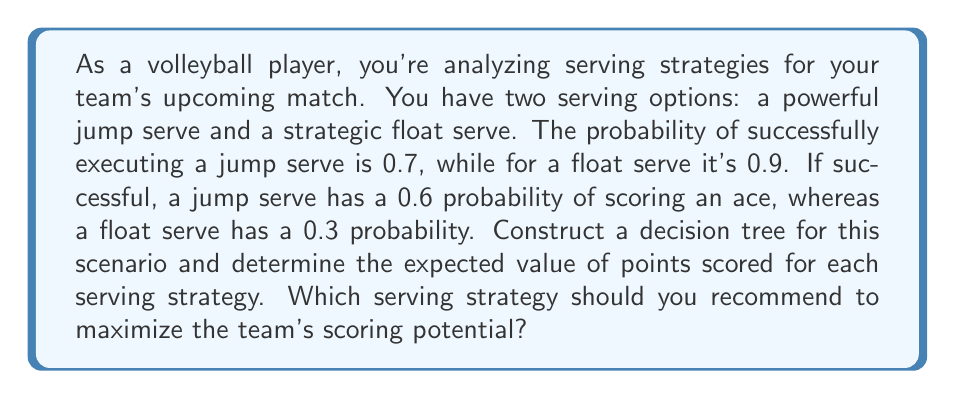What is the answer to this math problem? Let's approach this problem step by step using decision trees and expected value calculations:

1. Construct the decision tree:
   [asy]
   import geometry;
   
   size(300,200);
   
   pair A=(0,0), B=(100,50), C=(100,-50), D=(200,75), E=(200,25), F=(200,-25), G=(200,-75);
   
   draw(A--B--D);
   draw(B--E);
   draw(A--C--F);
   draw(C--G);
   
   label("Jump Serve", (A--B)/2, N);
   label("Float Serve", (A--C)/2, S);
   label("Success (0.7)", (B--D)/2, N);
   label("Fail (0.3)", (B--E)/2, S);
   label("Success (0.9)", (C--F)/2, N);
   label("Fail (0.1)", (C--G)/2, S);
   label("Ace (0.6)", D, E);
   label("No Ace (0.4)", E, E);
   label("Ace (0.3)", F, E);
   label("No Ace (0.7)", G, E);
   
   dot(A);
   dot(B);
   dot(C);
   dot(D);
   dot(E);
   dot(F);
   dot(G);
   [/asy]

2. Calculate the expected value for the Jump Serve:
   $$EV_{Jump} = 0.7 \cdot (0.6 \cdot 1 + 0.4 \cdot 0) + 0.3 \cdot 0$$
   $$EV_{Jump} = 0.7 \cdot 0.6 = 0.42$$

3. Calculate the expected value for the Float Serve:
   $$EV_{Float} = 0.9 \cdot (0.3 \cdot 1 + 0.7 \cdot 0) + 0.1 \cdot 0$$
   $$EV_{Float} = 0.9 \cdot 0.3 = 0.27$$

4. Compare the expected values:
   The Jump Serve has a higher expected value (0.42) compared to the Float Serve (0.27).

5. Interpret the results:
   The Jump Serve, despite having a lower success rate, has a higher probability of scoring an ace when successful. This leads to a higher expected value of points scored.
Answer: The Jump Serve strategy has a higher expected value of 0.42 points per serve, compared to 0.27 for the Float Serve. Therefore, you should recommend the Jump Serve strategy to maximize the team's scoring potential. 